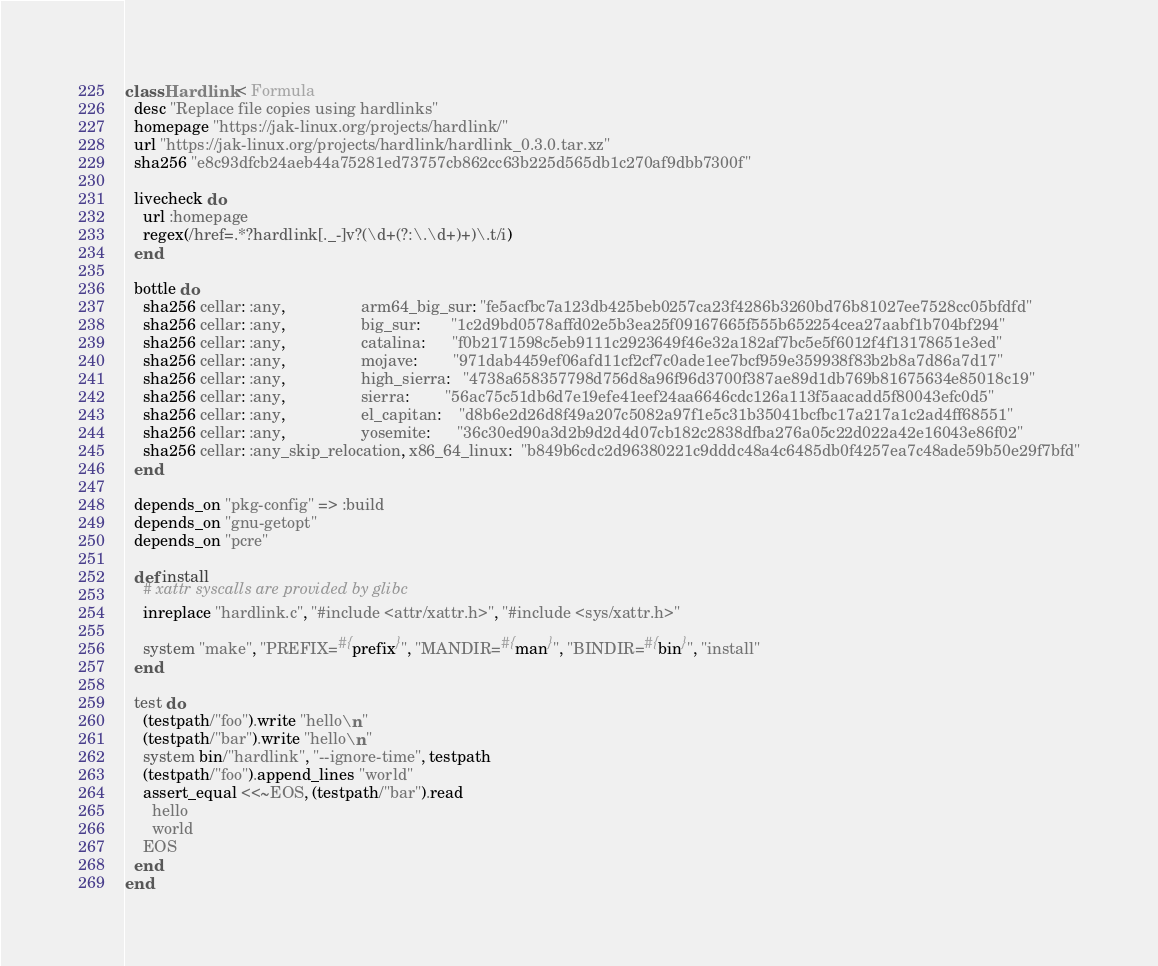Convert code to text. <code><loc_0><loc_0><loc_500><loc_500><_Ruby_>class Hardlink < Formula
  desc "Replace file copies using hardlinks"
  homepage "https://jak-linux.org/projects/hardlink/"
  url "https://jak-linux.org/projects/hardlink/hardlink_0.3.0.tar.xz"
  sha256 "e8c93dfcb24aeb44a75281ed73757cb862cc63b225d565db1c270af9dbb7300f"

  livecheck do
    url :homepage
    regex(/href=.*?hardlink[._-]v?(\d+(?:\.\d+)+)\.t/i)
  end

  bottle do
    sha256 cellar: :any,                 arm64_big_sur: "fe5acfbc7a123db425beb0257ca23f4286b3260bd76b81027ee7528cc05bfdfd"
    sha256 cellar: :any,                 big_sur:       "1c2d9bd0578affd02e5b3ea25f09167665f555b652254cea27aabf1b704bf294"
    sha256 cellar: :any,                 catalina:      "f0b2171598c5eb9111c2923649f46e32a182af7bc5e5f6012f4f13178651e3ed"
    sha256 cellar: :any,                 mojave:        "971dab4459ef06afd11cf2cf7c0ade1ee7bcf959e359938f83b2b8a7d86a7d17"
    sha256 cellar: :any,                 high_sierra:   "4738a658357798d756d8a96f96d3700f387ae89d1db769b81675634e85018c19"
    sha256 cellar: :any,                 sierra:        "56ac75c51db6d7e19efe41eef24aa6646cdc126a113f5aacadd5f80043efc0d5"
    sha256 cellar: :any,                 el_capitan:    "d8b6e2d26d8f49a207c5082a97f1e5c31b35041bcfbc17a217a1c2ad4ff68551"
    sha256 cellar: :any,                 yosemite:      "36c30ed90a3d2b9d2d4d07cb182c2838dfba276a05c22d022a42e16043e86f02"
    sha256 cellar: :any_skip_relocation, x86_64_linux:  "b849b6cdc2d96380221c9dddc48a4c6485db0f4257ea7c48ade59b50e29f7bfd"
  end

  depends_on "pkg-config" => :build
  depends_on "gnu-getopt"
  depends_on "pcre"

  def install
    # xattr syscalls are provided by glibc
    inreplace "hardlink.c", "#include <attr/xattr.h>", "#include <sys/xattr.h>"

    system "make", "PREFIX=#{prefix}", "MANDIR=#{man}", "BINDIR=#{bin}", "install"
  end

  test do
    (testpath/"foo").write "hello\n"
    (testpath/"bar").write "hello\n"
    system bin/"hardlink", "--ignore-time", testpath
    (testpath/"foo").append_lines "world"
    assert_equal <<~EOS, (testpath/"bar").read
      hello
      world
    EOS
  end
end
</code> 